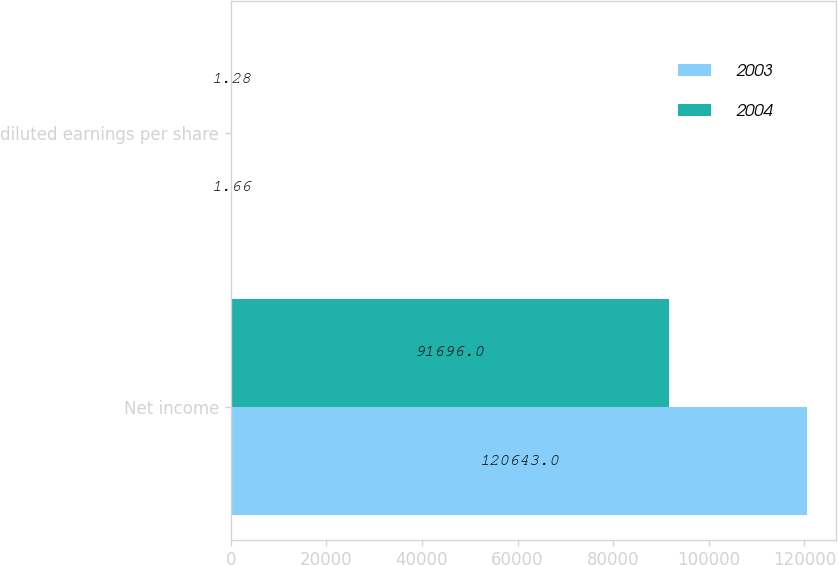Convert chart to OTSL. <chart><loc_0><loc_0><loc_500><loc_500><stacked_bar_chart><ecel><fcel>Net income<fcel>diluted earnings per share<nl><fcel>2003<fcel>120643<fcel>1.66<nl><fcel>2004<fcel>91696<fcel>1.28<nl></chart> 